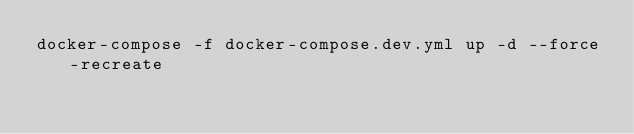<code> <loc_0><loc_0><loc_500><loc_500><_Bash_>docker-compose -f docker-compose.dev.yml up -d --force-recreate</code> 